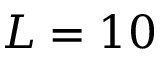<formula> <loc_0><loc_0><loc_500><loc_500>L = 1 0</formula> 